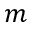Convert formula to latex. <formula><loc_0><loc_0><loc_500><loc_500>m</formula> 